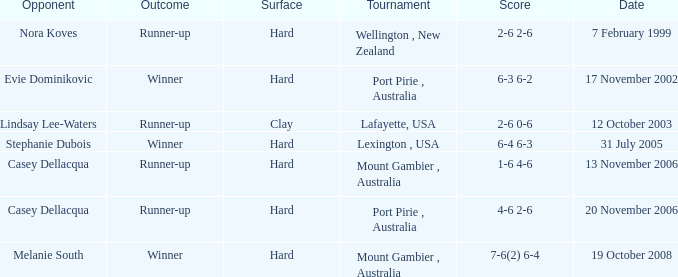Which Opponent is on 17 november 2002? Evie Dominikovic. 